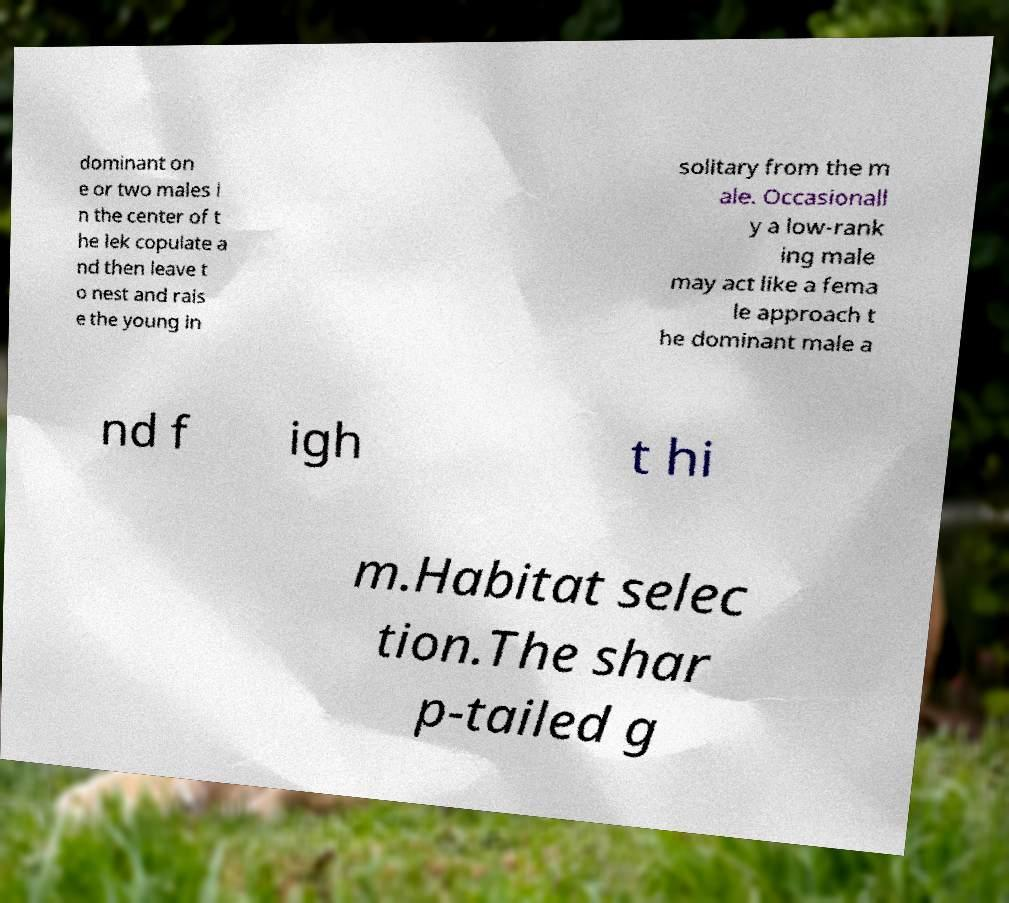What messages or text are displayed in this image? I need them in a readable, typed format. dominant on e or two males i n the center of t he lek copulate a nd then leave t o nest and rais e the young in solitary from the m ale. Occasionall y a low-rank ing male may act like a fema le approach t he dominant male a nd f igh t hi m.Habitat selec tion.The shar p-tailed g 